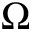Convert formula to latex. <formula><loc_0><loc_0><loc_500><loc_500>\Omega</formula> 